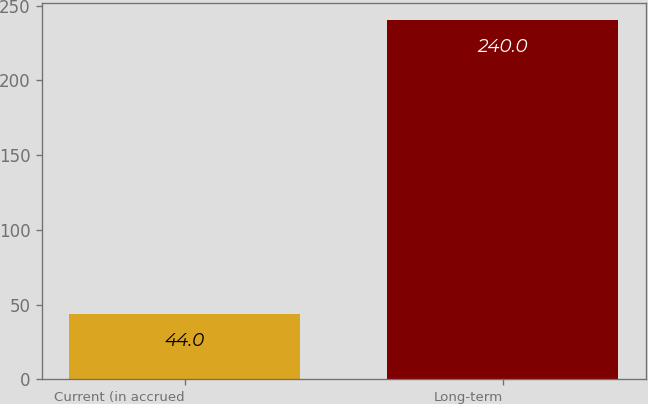<chart> <loc_0><loc_0><loc_500><loc_500><bar_chart><fcel>Current (in accrued<fcel>Long-term<nl><fcel>44<fcel>240<nl></chart> 